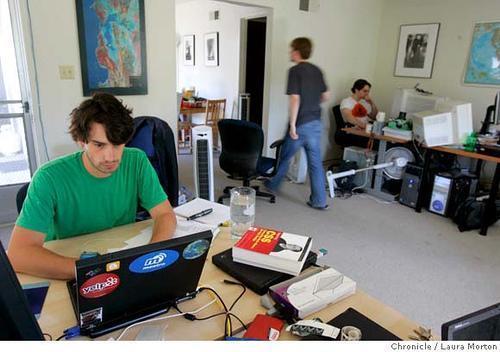How many people in the room?
Give a very brief answer. 3. How many people are leaving the room?
Give a very brief answer. 1. How many people are in the picture?
Give a very brief answer. 2. How many chairs are visible?
Give a very brief answer. 2. How many books are there?
Give a very brief answer. 2. 